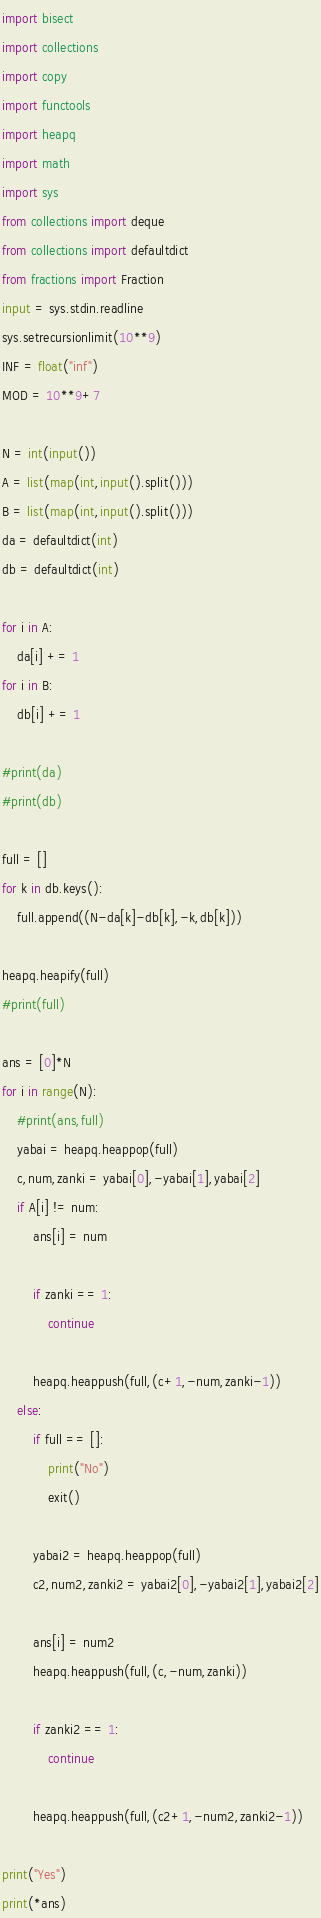<code> <loc_0><loc_0><loc_500><loc_500><_Python_>import bisect
import collections
import copy
import functools
import heapq
import math
import sys
from collections import deque
from collections import defaultdict
from fractions import Fraction
input = sys.stdin.readline
sys.setrecursionlimit(10**9)
INF = float("inf")
MOD = 10**9+7

N = int(input())
A = list(map(int,input().split()))
B = list(map(int,input().split()))
da = defaultdict(int)
db = defaultdict(int)

for i in A:
    da[i] += 1
for i in B:
    db[i] += 1

#print(da)
#print(db)

full = []
for k in db.keys():
    full.append((N-da[k]-db[k],-k,db[k]))

heapq.heapify(full)
#print(full)

ans = [0]*N
for i in range(N):
    #print(ans,full)
    yabai = heapq.heappop(full)
    c,num,zanki = yabai[0],-yabai[1],yabai[2]
    if A[i] != num:
        ans[i] = num

        if zanki == 1:
            continue

        heapq.heappush(full,(c+1,-num,zanki-1))
    else:
        if full == []:
            print("No")
            exit()

        yabai2 = heapq.heappop(full)
        c2,num2,zanki2 = yabai2[0],-yabai2[1],yabai2[2]

        ans[i] = num2
        heapq.heappush(full,(c,-num,zanki))

        if zanki2 == 1:
            continue

        heapq.heappush(full,(c2+1,-num2,zanki2-1))

print("Yes")
print(*ans)</code> 